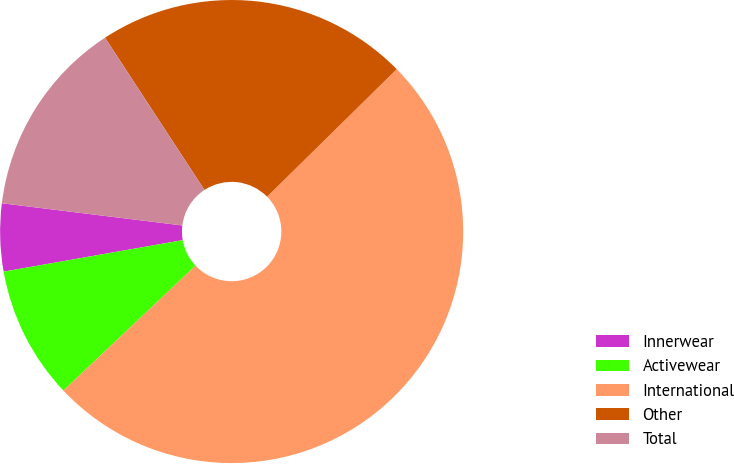Convert chart to OTSL. <chart><loc_0><loc_0><loc_500><loc_500><pie_chart><fcel>Innerwear<fcel>Activewear<fcel>International<fcel>Other<fcel>Total<nl><fcel>4.72%<fcel>9.28%<fcel>50.32%<fcel>21.84%<fcel>13.84%<nl></chart> 